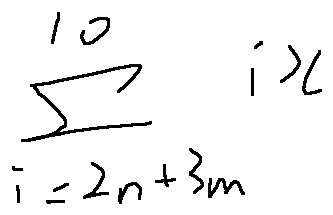<formula> <loc_0><loc_0><loc_500><loc_500>\sum \lim i t s _ { i = 2 n + 3 m } ^ { 1 0 } i x</formula> 